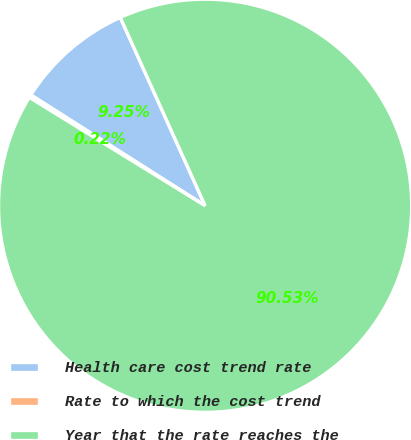<chart> <loc_0><loc_0><loc_500><loc_500><pie_chart><fcel>Health care cost trend rate<fcel>Rate to which the cost trend<fcel>Year that the rate reaches the<nl><fcel>9.25%<fcel>0.22%<fcel>90.52%<nl></chart> 